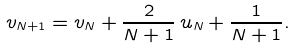<formula> <loc_0><loc_0><loc_500><loc_500>v _ { N + 1 } = v _ { N } + \frac { 2 } { N + 1 } \, u _ { N } + \frac { 1 } { N + 1 } .</formula> 